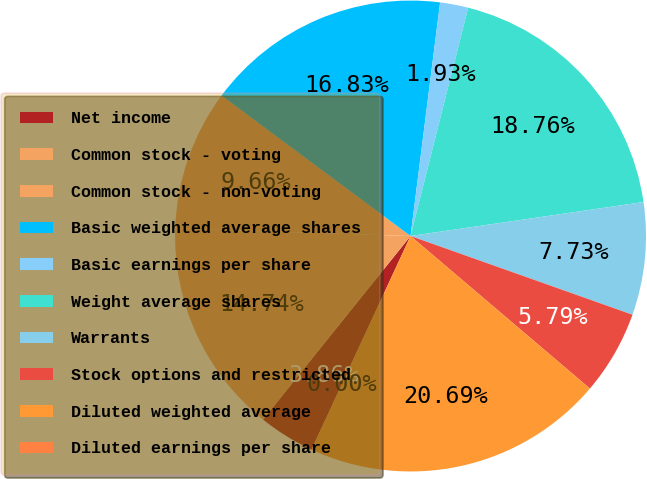Convert chart. <chart><loc_0><loc_0><loc_500><loc_500><pie_chart><fcel>Net income<fcel>Common stock - voting<fcel>Common stock - non-voting<fcel>Basic weighted average shares<fcel>Basic earnings per share<fcel>Weight average shares<fcel>Warrants<fcel>Stock options and restricted<fcel>Diluted weighted average<fcel>Diluted earnings per share<nl><fcel>3.86%<fcel>14.74%<fcel>9.66%<fcel>16.83%<fcel>1.93%<fcel>18.76%<fcel>7.73%<fcel>5.79%<fcel>20.69%<fcel>0.0%<nl></chart> 